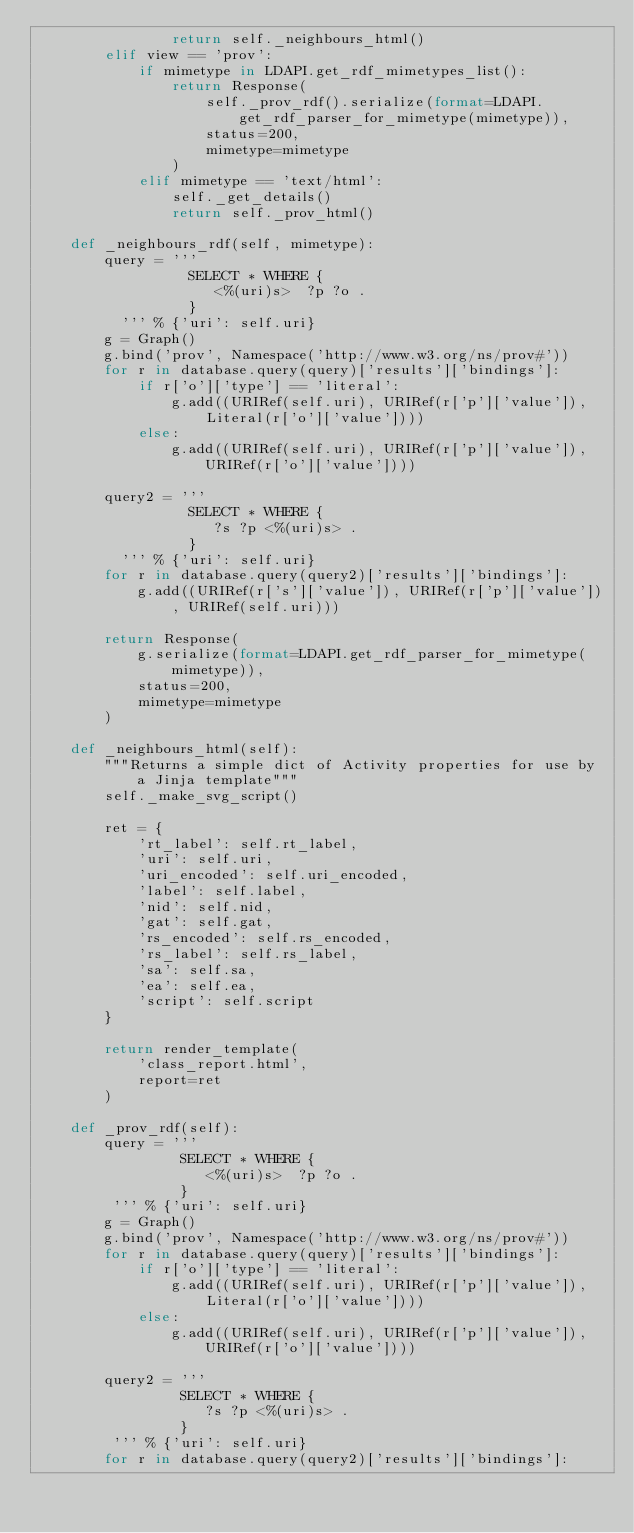Convert code to text. <code><loc_0><loc_0><loc_500><loc_500><_Python_>                return self._neighbours_html()
        elif view == 'prov':
            if mimetype in LDAPI.get_rdf_mimetypes_list():
                return Response(
                    self._prov_rdf().serialize(format=LDAPI.get_rdf_parser_for_mimetype(mimetype)),
                    status=200,
                    mimetype=mimetype
                )
            elif mimetype == 'text/html':
                self._get_details()
                return self._prov_html()

    def _neighbours_rdf(self, mimetype):
        query = '''
                  SELECT * WHERE {
                     <%(uri)s>  ?p ?o .
                  }
          ''' % {'uri': self.uri}
        g = Graph()
        g.bind('prov', Namespace('http://www.w3.org/ns/prov#'))
        for r in database.query(query)['results']['bindings']:
            if r['o']['type'] == 'literal':
                g.add((URIRef(self.uri), URIRef(r['p']['value']), Literal(r['o']['value'])))
            else:
                g.add((URIRef(self.uri), URIRef(r['p']['value']), URIRef(r['o']['value'])))

        query2 = '''
                  SELECT * WHERE {
                     ?s ?p <%(uri)s> .
                  }
          ''' % {'uri': self.uri}
        for r in database.query(query2)['results']['bindings']:
            g.add((URIRef(r['s']['value']), URIRef(r['p']['value']), URIRef(self.uri)))

        return Response(
            g.serialize(format=LDAPI.get_rdf_parser_for_mimetype(mimetype)),
            status=200,
            mimetype=mimetype
        )

    def _neighbours_html(self):
        """Returns a simple dict of Activity properties for use by a Jinja template"""
        self._make_svg_script()

        ret = {
            'rt_label': self.rt_label,
            'uri': self.uri,
            'uri_encoded': self.uri_encoded,
            'label': self.label,
            'nid': self.nid,
            'gat': self.gat,
            'rs_encoded': self.rs_encoded,
            'rs_label': self.rs_label,
            'sa': self.sa,
            'ea': self.ea,
            'script': self.script
        }

        return render_template(
            'class_report.html',
            report=ret
        )

    def _prov_rdf(self):
        query = '''
                 SELECT * WHERE {
                    <%(uri)s>  ?p ?o .
                 }
         ''' % {'uri': self.uri}
        g = Graph()
        g.bind('prov', Namespace('http://www.w3.org/ns/prov#'))
        for r in database.query(query)['results']['bindings']:
            if r['o']['type'] == 'literal':
                g.add((URIRef(self.uri), URIRef(r['p']['value']), Literal(r['o']['value'])))
            else:
                g.add((URIRef(self.uri), URIRef(r['p']['value']), URIRef(r['o']['value'])))

        query2 = '''
                 SELECT * WHERE {
                    ?s ?p <%(uri)s> .
                 }
         ''' % {'uri': self.uri}
        for r in database.query(query2)['results']['bindings']:</code> 